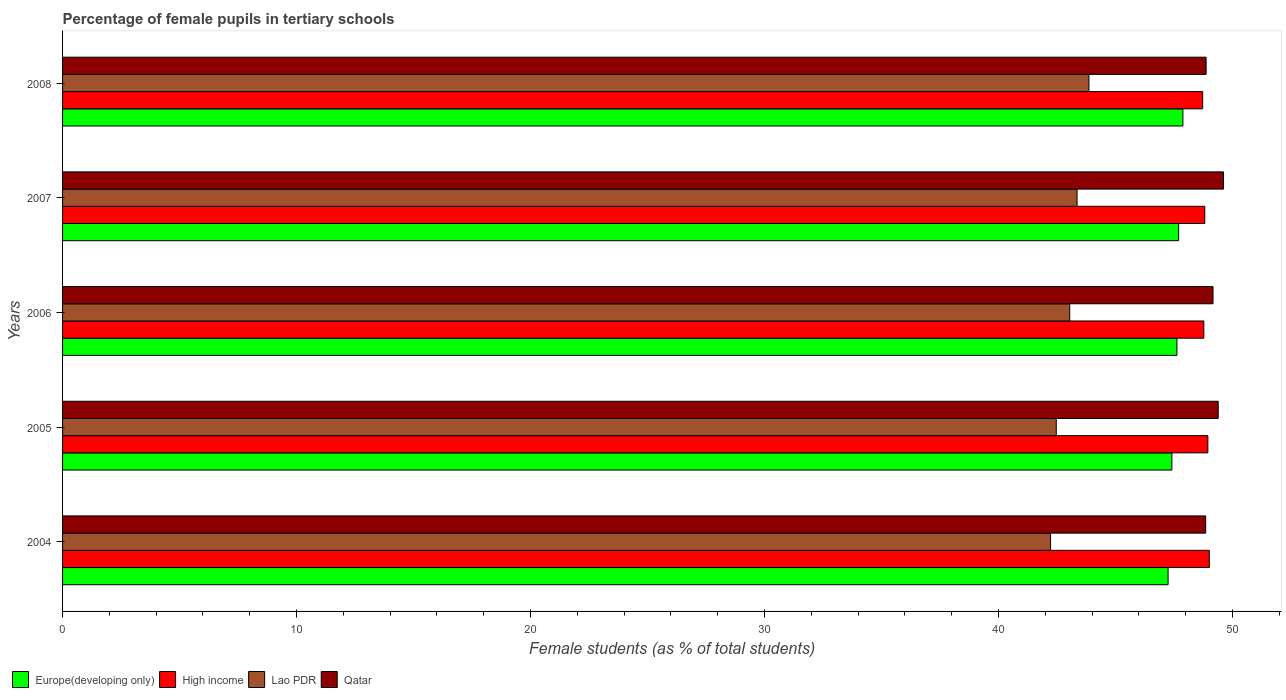How many different coloured bars are there?
Ensure brevity in your answer.  4. How many groups of bars are there?
Your answer should be compact. 5. Are the number of bars per tick equal to the number of legend labels?
Provide a short and direct response. Yes. How many bars are there on the 5th tick from the top?
Give a very brief answer. 4. What is the percentage of female pupils in tertiary schools in Lao PDR in 2006?
Your answer should be compact. 43.05. Across all years, what is the maximum percentage of female pupils in tertiary schools in Lao PDR?
Make the answer very short. 43.87. Across all years, what is the minimum percentage of female pupils in tertiary schools in Lao PDR?
Your answer should be compact. 42.23. In which year was the percentage of female pupils in tertiary schools in Qatar maximum?
Your answer should be very brief. 2007. What is the total percentage of female pupils in tertiary schools in Europe(developing only) in the graph?
Offer a very short reply. 237.87. What is the difference between the percentage of female pupils in tertiary schools in High income in 2004 and that in 2005?
Offer a very short reply. 0.06. What is the difference between the percentage of female pupils in tertiary schools in Europe(developing only) in 2004 and the percentage of female pupils in tertiary schools in Qatar in 2008?
Make the answer very short. -1.62. What is the average percentage of female pupils in tertiary schools in High income per year?
Provide a short and direct response. 48.85. In the year 2004, what is the difference between the percentage of female pupils in tertiary schools in High income and percentage of female pupils in tertiary schools in Europe(developing only)?
Your answer should be compact. 1.76. What is the ratio of the percentage of female pupils in tertiary schools in High income in 2005 to that in 2008?
Keep it short and to the point. 1. What is the difference between the highest and the second highest percentage of female pupils in tertiary schools in High income?
Provide a short and direct response. 0.06. What is the difference between the highest and the lowest percentage of female pupils in tertiary schools in Lao PDR?
Your answer should be very brief. 1.64. Is it the case that in every year, the sum of the percentage of female pupils in tertiary schools in Europe(developing only) and percentage of female pupils in tertiary schools in Qatar is greater than the sum of percentage of female pupils in tertiary schools in High income and percentage of female pupils in tertiary schools in Lao PDR?
Give a very brief answer. Yes. What does the 3rd bar from the top in 2004 represents?
Your answer should be compact. High income. What does the 4th bar from the bottom in 2007 represents?
Offer a terse response. Qatar. How many bars are there?
Your answer should be very brief. 20. Are the values on the major ticks of X-axis written in scientific E-notation?
Make the answer very short. No. How are the legend labels stacked?
Offer a very short reply. Horizontal. What is the title of the graph?
Offer a terse response. Percentage of female pupils in tertiary schools. Does "Suriname" appear as one of the legend labels in the graph?
Offer a terse response. No. What is the label or title of the X-axis?
Provide a succinct answer. Female students (as % of total students). What is the Female students (as % of total students) of Europe(developing only) in 2004?
Ensure brevity in your answer.  47.25. What is the Female students (as % of total students) in High income in 2004?
Your response must be concise. 49.01. What is the Female students (as % of total students) of Lao PDR in 2004?
Offer a very short reply. 42.23. What is the Female students (as % of total students) in Qatar in 2004?
Offer a terse response. 48.86. What is the Female students (as % of total students) of Europe(developing only) in 2005?
Offer a very short reply. 47.41. What is the Female students (as % of total students) in High income in 2005?
Offer a terse response. 48.95. What is the Female students (as % of total students) of Lao PDR in 2005?
Your answer should be very brief. 42.47. What is the Female students (as % of total students) in Qatar in 2005?
Keep it short and to the point. 49.39. What is the Female students (as % of total students) in Europe(developing only) in 2006?
Your answer should be compact. 47.63. What is the Female students (as % of total students) of High income in 2006?
Offer a very short reply. 48.78. What is the Female students (as % of total students) in Lao PDR in 2006?
Ensure brevity in your answer.  43.05. What is the Female students (as % of total students) in Qatar in 2006?
Provide a short and direct response. 49.17. What is the Female students (as % of total students) of Europe(developing only) in 2007?
Provide a short and direct response. 47.7. What is the Female students (as % of total students) of High income in 2007?
Make the answer very short. 48.82. What is the Female students (as % of total students) in Lao PDR in 2007?
Provide a succinct answer. 43.36. What is the Female students (as % of total students) in Qatar in 2007?
Ensure brevity in your answer.  49.61. What is the Female students (as % of total students) in Europe(developing only) in 2008?
Your response must be concise. 47.88. What is the Female students (as % of total students) in High income in 2008?
Keep it short and to the point. 48.72. What is the Female students (as % of total students) in Lao PDR in 2008?
Provide a succinct answer. 43.87. What is the Female students (as % of total students) of Qatar in 2008?
Provide a short and direct response. 48.87. Across all years, what is the maximum Female students (as % of total students) in Europe(developing only)?
Provide a succinct answer. 47.88. Across all years, what is the maximum Female students (as % of total students) in High income?
Offer a very short reply. 49.01. Across all years, what is the maximum Female students (as % of total students) in Lao PDR?
Your answer should be very brief. 43.87. Across all years, what is the maximum Female students (as % of total students) in Qatar?
Provide a succinct answer. 49.61. Across all years, what is the minimum Female students (as % of total students) in Europe(developing only)?
Offer a terse response. 47.25. Across all years, what is the minimum Female students (as % of total students) in High income?
Provide a short and direct response. 48.72. Across all years, what is the minimum Female students (as % of total students) in Lao PDR?
Your response must be concise. 42.23. Across all years, what is the minimum Female students (as % of total students) of Qatar?
Your answer should be very brief. 48.86. What is the total Female students (as % of total students) in Europe(developing only) in the graph?
Provide a succinct answer. 237.87. What is the total Female students (as % of total students) in High income in the graph?
Your response must be concise. 244.27. What is the total Female students (as % of total students) of Lao PDR in the graph?
Ensure brevity in your answer.  214.96. What is the total Female students (as % of total students) of Qatar in the graph?
Offer a very short reply. 245.9. What is the difference between the Female students (as % of total students) in Europe(developing only) in 2004 and that in 2005?
Make the answer very short. -0.16. What is the difference between the Female students (as % of total students) in High income in 2004 and that in 2005?
Offer a terse response. 0.06. What is the difference between the Female students (as % of total students) of Lao PDR in 2004 and that in 2005?
Offer a terse response. -0.24. What is the difference between the Female students (as % of total students) of Qatar in 2004 and that in 2005?
Provide a succinct answer. -0.54. What is the difference between the Female students (as % of total students) in Europe(developing only) in 2004 and that in 2006?
Your answer should be compact. -0.38. What is the difference between the Female students (as % of total students) of High income in 2004 and that in 2006?
Provide a short and direct response. 0.23. What is the difference between the Female students (as % of total students) of Lao PDR in 2004 and that in 2006?
Provide a succinct answer. -0.82. What is the difference between the Female students (as % of total students) of Qatar in 2004 and that in 2006?
Your answer should be compact. -0.31. What is the difference between the Female students (as % of total students) in Europe(developing only) in 2004 and that in 2007?
Give a very brief answer. -0.45. What is the difference between the Female students (as % of total students) of High income in 2004 and that in 2007?
Provide a short and direct response. 0.19. What is the difference between the Female students (as % of total students) of Lao PDR in 2004 and that in 2007?
Give a very brief answer. -1.13. What is the difference between the Female students (as % of total students) in Qatar in 2004 and that in 2007?
Make the answer very short. -0.76. What is the difference between the Female students (as % of total students) in Europe(developing only) in 2004 and that in 2008?
Your answer should be compact. -0.63. What is the difference between the Female students (as % of total students) of High income in 2004 and that in 2008?
Your response must be concise. 0.28. What is the difference between the Female students (as % of total students) in Lao PDR in 2004 and that in 2008?
Ensure brevity in your answer.  -1.64. What is the difference between the Female students (as % of total students) of Qatar in 2004 and that in 2008?
Offer a very short reply. -0.02. What is the difference between the Female students (as % of total students) of Europe(developing only) in 2005 and that in 2006?
Offer a terse response. -0.22. What is the difference between the Female students (as % of total students) in High income in 2005 and that in 2006?
Offer a terse response. 0.17. What is the difference between the Female students (as % of total students) in Lao PDR in 2005 and that in 2006?
Offer a terse response. -0.58. What is the difference between the Female students (as % of total students) in Qatar in 2005 and that in 2006?
Offer a very short reply. 0.22. What is the difference between the Female students (as % of total students) of Europe(developing only) in 2005 and that in 2007?
Offer a very short reply. -0.29. What is the difference between the Female students (as % of total students) of High income in 2005 and that in 2007?
Provide a short and direct response. 0.13. What is the difference between the Female students (as % of total students) in Lao PDR in 2005 and that in 2007?
Your answer should be very brief. -0.89. What is the difference between the Female students (as % of total students) of Qatar in 2005 and that in 2007?
Make the answer very short. -0.22. What is the difference between the Female students (as % of total students) in Europe(developing only) in 2005 and that in 2008?
Make the answer very short. -0.47. What is the difference between the Female students (as % of total students) in High income in 2005 and that in 2008?
Provide a short and direct response. 0.22. What is the difference between the Female students (as % of total students) in Lao PDR in 2005 and that in 2008?
Your response must be concise. -1.4. What is the difference between the Female students (as % of total students) in Qatar in 2005 and that in 2008?
Offer a very short reply. 0.52. What is the difference between the Female students (as % of total students) of Europe(developing only) in 2006 and that in 2007?
Make the answer very short. -0.07. What is the difference between the Female students (as % of total students) in High income in 2006 and that in 2007?
Provide a short and direct response. -0.04. What is the difference between the Female students (as % of total students) of Lao PDR in 2006 and that in 2007?
Make the answer very short. -0.31. What is the difference between the Female students (as % of total students) in Qatar in 2006 and that in 2007?
Your answer should be compact. -0.45. What is the difference between the Female students (as % of total students) of Europe(developing only) in 2006 and that in 2008?
Your response must be concise. -0.25. What is the difference between the Female students (as % of total students) in High income in 2006 and that in 2008?
Provide a short and direct response. 0.05. What is the difference between the Female students (as % of total students) in Lao PDR in 2006 and that in 2008?
Your answer should be compact. -0.82. What is the difference between the Female students (as % of total students) in Qatar in 2006 and that in 2008?
Your response must be concise. 0.29. What is the difference between the Female students (as % of total students) in Europe(developing only) in 2007 and that in 2008?
Your response must be concise. -0.18. What is the difference between the Female students (as % of total students) of High income in 2007 and that in 2008?
Provide a short and direct response. 0.09. What is the difference between the Female students (as % of total students) of Lao PDR in 2007 and that in 2008?
Offer a terse response. -0.51. What is the difference between the Female students (as % of total students) of Qatar in 2007 and that in 2008?
Your answer should be very brief. 0.74. What is the difference between the Female students (as % of total students) in Europe(developing only) in 2004 and the Female students (as % of total students) in High income in 2005?
Your answer should be compact. -1.7. What is the difference between the Female students (as % of total students) in Europe(developing only) in 2004 and the Female students (as % of total students) in Lao PDR in 2005?
Provide a succinct answer. 4.78. What is the difference between the Female students (as % of total students) of Europe(developing only) in 2004 and the Female students (as % of total students) of Qatar in 2005?
Offer a terse response. -2.14. What is the difference between the Female students (as % of total students) in High income in 2004 and the Female students (as % of total students) in Lao PDR in 2005?
Your response must be concise. 6.54. What is the difference between the Female students (as % of total students) in High income in 2004 and the Female students (as % of total students) in Qatar in 2005?
Keep it short and to the point. -0.38. What is the difference between the Female students (as % of total students) in Lao PDR in 2004 and the Female students (as % of total students) in Qatar in 2005?
Your answer should be very brief. -7.17. What is the difference between the Female students (as % of total students) in Europe(developing only) in 2004 and the Female students (as % of total students) in High income in 2006?
Keep it short and to the point. -1.53. What is the difference between the Female students (as % of total students) in Europe(developing only) in 2004 and the Female students (as % of total students) in Lao PDR in 2006?
Your response must be concise. 4.2. What is the difference between the Female students (as % of total students) in Europe(developing only) in 2004 and the Female students (as % of total students) in Qatar in 2006?
Your answer should be compact. -1.92. What is the difference between the Female students (as % of total students) of High income in 2004 and the Female students (as % of total students) of Lao PDR in 2006?
Your answer should be very brief. 5.96. What is the difference between the Female students (as % of total students) in High income in 2004 and the Female students (as % of total students) in Qatar in 2006?
Give a very brief answer. -0.16. What is the difference between the Female students (as % of total students) in Lao PDR in 2004 and the Female students (as % of total students) in Qatar in 2006?
Your answer should be compact. -6.94. What is the difference between the Female students (as % of total students) in Europe(developing only) in 2004 and the Female students (as % of total students) in High income in 2007?
Give a very brief answer. -1.57. What is the difference between the Female students (as % of total students) in Europe(developing only) in 2004 and the Female students (as % of total students) in Lao PDR in 2007?
Make the answer very short. 3.89. What is the difference between the Female students (as % of total students) of Europe(developing only) in 2004 and the Female students (as % of total students) of Qatar in 2007?
Make the answer very short. -2.37. What is the difference between the Female students (as % of total students) in High income in 2004 and the Female students (as % of total students) in Lao PDR in 2007?
Keep it short and to the point. 5.65. What is the difference between the Female students (as % of total students) in High income in 2004 and the Female students (as % of total students) in Qatar in 2007?
Make the answer very short. -0.6. What is the difference between the Female students (as % of total students) of Lao PDR in 2004 and the Female students (as % of total students) of Qatar in 2007?
Provide a succinct answer. -7.39. What is the difference between the Female students (as % of total students) in Europe(developing only) in 2004 and the Female students (as % of total students) in High income in 2008?
Offer a very short reply. -1.48. What is the difference between the Female students (as % of total students) in Europe(developing only) in 2004 and the Female students (as % of total students) in Lao PDR in 2008?
Provide a short and direct response. 3.38. What is the difference between the Female students (as % of total students) in Europe(developing only) in 2004 and the Female students (as % of total students) in Qatar in 2008?
Your answer should be compact. -1.62. What is the difference between the Female students (as % of total students) in High income in 2004 and the Female students (as % of total students) in Lao PDR in 2008?
Give a very brief answer. 5.14. What is the difference between the Female students (as % of total students) of High income in 2004 and the Female students (as % of total students) of Qatar in 2008?
Your answer should be compact. 0.14. What is the difference between the Female students (as % of total students) in Lao PDR in 2004 and the Female students (as % of total students) in Qatar in 2008?
Ensure brevity in your answer.  -6.65. What is the difference between the Female students (as % of total students) in Europe(developing only) in 2005 and the Female students (as % of total students) in High income in 2006?
Your response must be concise. -1.36. What is the difference between the Female students (as % of total students) in Europe(developing only) in 2005 and the Female students (as % of total students) in Lao PDR in 2006?
Make the answer very short. 4.37. What is the difference between the Female students (as % of total students) of Europe(developing only) in 2005 and the Female students (as % of total students) of Qatar in 2006?
Provide a succinct answer. -1.76. What is the difference between the Female students (as % of total students) in High income in 2005 and the Female students (as % of total students) in Lao PDR in 2006?
Make the answer very short. 5.9. What is the difference between the Female students (as % of total students) in High income in 2005 and the Female students (as % of total students) in Qatar in 2006?
Provide a succinct answer. -0.22. What is the difference between the Female students (as % of total students) in Lao PDR in 2005 and the Female students (as % of total students) in Qatar in 2006?
Your response must be concise. -6.7. What is the difference between the Female students (as % of total students) of Europe(developing only) in 2005 and the Female students (as % of total students) of High income in 2007?
Give a very brief answer. -1.41. What is the difference between the Female students (as % of total students) of Europe(developing only) in 2005 and the Female students (as % of total students) of Lao PDR in 2007?
Provide a short and direct response. 4.05. What is the difference between the Female students (as % of total students) in Europe(developing only) in 2005 and the Female students (as % of total students) in Qatar in 2007?
Ensure brevity in your answer.  -2.2. What is the difference between the Female students (as % of total students) in High income in 2005 and the Female students (as % of total students) in Lao PDR in 2007?
Your answer should be very brief. 5.59. What is the difference between the Female students (as % of total students) of High income in 2005 and the Female students (as % of total students) of Qatar in 2007?
Your response must be concise. -0.67. What is the difference between the Female students (as % of total students) in Lao PDR in 2005 and the Female students (as % of total students) in Qatar in 2007?
Offer a terse response. -7.14. What is the difference between the Female students (as % of total students) in Europe(developing only) in 2005 and the Female students (as % of total students) in High income in 2008?
Offer a terse response. -1.31. What is the difference between the Female students (as % of total students) in Europe(developing only) in 2005 and the Female students (as % of total students) in Lao PDR in 2008?
Give a very brief answer. 3.54. What is the difference between the Female students (as % of total students) of Europe(developing only) in 2005 and the Female students (as % of total students) of Qatar in 2008?
Provide a short and direct response. -1.46. What is the difference between the Female students (as % of total students) of High income in 2005 and the Female students (as % of total students) of Lao PDR in 2008?
Your answer should be compact. 5.08. What is the difference between the Female students (as % of total students) in High income in 2005 and the Female students (as % of total students) in Qatar in 2008?
Provide a short and direct response. 0.07. What is the difference between the Female students (as % of total students) in Lao PDR in 2005 and the Female students (as % of total students) in Qatar in 2008?
Provide a succinct answer. -6.4. What is the difference between the Female students (as % of total students) of Europe(developing only) in 2006 and the Female students (as % of total students) of High income in 2007?
Give a very brief answer. -1.19. What is the difference between the Female students (as % of total students) of Europe(developing only) in 2006 and the Female students (as % of total students) of Lao PDR in 2007?
Your response must be concise. 4.27. What is the difference between the Female students (as % of total students) of Europe(developing only) in 2006 and the Female students (as % of total students) of Qatar in 2007?
Offer a terse response. -1.99. What is the difference between the Female students (as % of total students) of High income in 2006 and the Female students (as % of total students) of Lao PDR in 2007?
Offer a terse response. 5.42. What is the difference between the Female students (as % of total students) in High income in 2006 and the Female students (as % of total students) in Qatar in 2007?
Provide a short and direct response. -0.84. What is the difference between the Female students (as % of total students) in Lao PDR in 2006 and the Female students (as % of total students) in Qatar in 2007?
Make the answer very short. -6.57. What is the difference between the Female students (as % of total students) of Europe(developing only) in 2006 and the Female students (as % of total students) of High income in 2008?
Provide a succinct answer. -1.1. What is the difference between the Female students (as % of total students) in Europe(developing only) in 2006 and the Female students (as % of total students) in Lao PDR in 2008?
Make the answer very short. 3.76. What is the difference between the Female students (as % of total students) of Europe(developing only) in 2006 and the Female students (as % of total students) of Qatar in 2008?
Your answer should be very brief. -1.25. What is the difference between the Female students (as % of total students) in High income in 2006 and the Female students (as % of total students) in Lao PDR in 2008?
Your response must be concise. 4.91. What is the difference between the Female students (as % of total students) in High income in 2006 and the Female students (as % of total students) in Qatar in 2008?
Provide a succinct answer. -0.1. What is the difference between the Female students (as % of total students) in Lao PDR in 2006 and the Female students (as % of total students) in Qatar in 2008?
Offer a very short reply. -5.83. What is the difference between the Female students (as % of total students) in Europe(developing only) in 2007 and the Female students (as % of total students) in High income in 2008?
Your answer should be very brief. -1.02. What is the difference between the Female students (as % of total students) in Europe(developing only) in 2007 and the Female students (as % of total students) in Lao PDR in 2008?
Make the answer very short. 3.83. What is the difference between the Female students (as % of total students) of Europe(developing only) in 2007 and the Female students (as % of total students) of Qatar in 2008?
Your answer should be very brief. -1.17. What is the difference between the Female students (as % of total students) in High income in 2007 and the Female students (as % of total students) in Lao PDR in 2008?
Ensure brevity in your answer.  4.95. What is the difference between the Female students (as % of total students) in High income in 2007 and the Female students (as % of total students) in Qatar in 2008?
Give a very brief answer. -0.06. What is the difference between the Female students (as % of total students) in Lao PDR in 2007 and the Female students (as % of total students) in Qatar in 2008?
Offer a terse response. -5.52. What is the average Female students (as % of total students) of Europe(developing only) per year?
Provide a succinct answer. 47.57. What is the average Female students (as % of total students) in High income per year?
Your answer should be compact. 48.85. What is the average Female students (as % of total students) of Lao PDR per year?
Keep it short and to the point. 42.99. What is the average Female students (as % of total students) in Qatar per year?
Provide a succinct answer. 49.18. In the year 2004, what is the difference between the Female students (as % of total students) of Europe(developing only) and Female students (as % of total students) of High income?
Provide a short and direct response. -1.76. In the year 2004, what is the difference between the Female students (as % of total students) in Europe(developing only) and Female students (as % of total students) in Lao PDR?
Provide a succinct answer. 5.02. In the year 2004, what is the difference between the Female students (as % of total students) in Europe(developing only) and Female students (as % of total students) in Qatar?
Your response must be concise. -1.61. In the year 2004, what is the difference between the Female students (as % of total students) in High income and Female students (as % of total students) in Lao PDR?
Provide a succinct answer. 6.78. In the year 2004, what is the difference between the Female students (as % of total students) in High income and Female students (as % of total students) in Qatar?
Your answer should be very brief. 0.15. In the year 2004, what is the difference between the Female students (as % of total students) of Lao PDR and Female students (as % of total students) of Qatar?
Offer a very short reply. -6.63. In the year 2005, what is the difference between the Female students (as % of total students) of Europe(developing only) and Female students (as % of total students) of High income?
Offer a very short reply. -1.54. In the year 2005, what is the difference between the Female students (as % of total students) of Europe(developing only) and Female students (as % of total students) of Lao PDR?
Offer a very short reply. 4.94. In the year 2005, what is the difference between the Female students (as % of total students) in Europe(developing only) and Female students (as % of total students) in Qatar?
Keep it short and to the point. -1.98. In the year 2005, what is the difference between the Female students (as % of total students) in High income and Female students (as % of total students) in Lao PDR?
Offer a terse response. 6.48. In the year 2005, what is the difference between the Female students (as % of total students) of High income and Female students (as % of total students) of Qatar?
Provide a short and direct response. -0.44. In the year 2005, what is the difference between the Female students (as % of total students) in Lao PDR and Female students (as % of total students) in Qatar?
Provide a short and direct response. -6.92. In the year 2006, what is the difference between the Female students (as % of total students) in Europe(developing only) and Female students (as % of total students) in High income?
Make the answer very short. -1.15. In the year 2006, what is the difference between the Female students (as % of total students) in Europe(developing only) and Female students (as % of total students) in Lao PDR?
Ensure brevity in your answer.  4.58. In the year 2006, what is the difference between the Female students (as % of total students) of Europe(developing only) and Female students (as % of total students) of Qatar?
Ensure brevity in your answer.  -1.54. In the year 2006, what is the difference between the Female students (as % of total students) of High income and Female students (as % of total students) of Lao PDR?
Ensure brevity in your answer.  5.73. In the year 2006, what is the difference between the Female students (as % of total students) of High income and Female students (as % of total students) of Qatar?
Make the answer very short. -0.39. In the year 2006, what is the difference between the Female students (as % of total students) of Lao PDR and Female students (as % of total students) of Qatar?
Provide a short and direct response. -6.12. In the year 2007, what is the difference between the Female students (as % of total students) in Europe(developing only) and Female students (as % of total students) in High income?
Give a very brief answer. -1.12. In the year 2007, what is the difference between the Female students (as % of total students) in Europe(developing only) and Female students (as % of total students) in Lao PDR?
Your response must be concise. 4.34. In the year 2007, what is the difference between the Female students (as % of total students) of Europe(developing only) and Female students (as % of total students) of Qatar?
Provide a succinct answer. -1.91. In the year 2007, what is the difference between the Female students (as % of total students) of High income and Female students (as % of total students) of Lao PDR?
Your answer should be very brief. 5.46. In the year 2007, what is the difference between the Female students (as % of total students) of High income and Female students (as % of total students) of Qatar?
Your answer should be very brief. -0.8. In the year 2007, what is the difference between the Female students (as % of total students) in Lao PDR and Female students (as % of total students) in Qatar?
Your answer should be very brief. -6.26. In the year 2008, what is the difference between the Female students (as % of total students) in Europe(developing only) and Female students (as % of total students) in High income?
Ensure brevity in your answer.  -0.84. In the year 2008, what is the difference between the Female students (as % of total students) of Europe(developing only) and Female students (as % of total students) of Lao PDR?
Provide a succinct answer. 4.02. In the year 2008, what is the difference between the Female students (as % of total students) in Europe(developing only) and Female students (as % of total students) in Qatar?
Provide a succinct answer. -0.99. In the year 2008, what is the difference between the Female students (as % of total students) of High income and Female students (as % of total students) of Lao PDR?
Make the answer very short. 4.86. In the year 2008, what is the difference between the Female students (as % of total students) of High income and Female students (as % of total students) of Qatar?
Ensure brevity in your answer.  -0.15. In the year 2008, what is the difference between the Female students (as % of total students) of Lao PDR and Female students (as % of total students) of Qatar?
Keep it short and to the point. -5.01. What is the ratio of the Female students (as % of total students) in Europe(developing only) in 2004 to that in 2005?
Keep it short and to the point. 1. What is the ratio of the Female students (as % of total students) of Qatar in 2004 to that in 2005?
Your answer should be compact. 0.99. What is the ratio of the Female students (as % of total students) of Europe(developing only) in 2004 to that in 2006?
Your answer should be compact. 0.99. What is the ratio of the Female students (as % of total students) of High income in 2004 to that in 2006?
Offer a terse response. 1. What is the ratio of the Female students (as % of total students) of Lao PDR in 2004 to that in 2006?
Your response must be concise. 0.98. What is the ratio of the Female students (as % of total students) of Qatar in 2004 to that in 2006?
Offer a very short reply. 0.99. What is the ratio of the Female students (as % of total students) of Lao PDR in 2004 to that in 2007?
Offer a terse response. 0.97. What is the ratio of the Female students (as % of total students) of Qatar in 2004 to that in 2007?
Keep it short and to the point. 0.98. What is the ratio of the Female students (as % of total students) in Europe(developing only) in 2004 to that in 2008?
Offer a very short reply. 0.99. What is the ratio of the Female students (as % of total students) of High income in 2004 to that in 2008?
Keep it short and to the point. 1.01. What is the ratio of the Female students (as % of total students) in Lao PDR in 2004 to that in 2008?
Keep it short and to the point. 0.96. What is the ratio of the Female students (as % of total students) of Qatar in 2004 to that in 2008?
Provide a short and direct response. 1. What is the ratio of the Female students (as % of total students) of Europe(developing only) in 2005 to that in 2006?
Your answer should be compact. 1. What is the ratio of the Female students (as % of total students) in Lao PDR in 2005 to that in 2006?
Your response must be concise. 0.99. What is the ratio of the Female students (as % of total students) in Qatar in 2005 to that in 2006?
Your answer should be very brief. 1. What is the ratio of the Female students (as % of total students) in Europe(developing only) in 2005 to that in 2007?
Your answer should be compact. 0.99. What is the ratio of the Female students (as % of total students) in Lao PDR in 2005 to that in 2007?
Keep it short and to the point. 0.98. What is the ratio of the Female students (as % of total students) in Qatar in 2005 to that in 2007?
Your answer should be very brief. 1. What is the ratio of the Female students (as % of total students) of Europe(developing only) in 2005 to that in 2008?
Provide a succinct answer. 0.99. What is the ratio of the Female students (as % of total students) in Lao PDR in 2005 to that in 2008?
Offer a terse response. 0.97. What is the ratio of the Female students (as % of total students) of Qatar in 2005 to that in 2008?
Your answer should be very brief. 1.01. What is the ratio of the Female students (as % of total students) of Europe(developing only) in 2006 to that in 2007?
Ensure brevity in your answer.  1. What is the ratio of the Female students (as % of total students) of Qatar in 2006 to that in 2007?
Provide a short and direct response. 0.99. What is the ratio of the Female students (as % of total students) in Europe(developing only) in 2006 to that in 2008?
Ensure brevity in your answer.  0.99. What is the ratio of the Female students (as % of total students) of High income in 2006 to that in 2008?
Make the answer very short. 1. What is the ratio of the Female students (as % of total students) in Lao PDR in 2006 to that in 2008?
Ensure brevity in your answer.  0.98. What is the ratio of the Female students (as % of total students) of Qatar in 2006 to that in 2008?
Your answer should be very brief. 1.01. What is the ratio of the Female students (as % of total students) in High income in 2007 to that in 2008?
Offer a terse response. 1. What is the ratio of the Female students (as % of total students) of Lao PDR in 2007 to that in 2008?
Offer a very short reply. 0.99. What is the ratio of the Female students (as % of total students) in Qatar in 2007 to that in 2008?
Your answer should be very brief. 1.02. What is the difference between the highest and the second highest Female students (as % of total students) of Europe(developing only)?
Provide a short and direct response. 0.18. What is the difference between the highest and the second highest Female students (as % of total students) in High income?
Provide a short and direct response. 0.06. What is the difference between the highest and the second highest Female students (as % of total students) in Lao PDR?
Your answer should be very brief. 0.51. What is the difference between the highest and the second highest Female students (as % of total students) of Qatar?
Your answer should be compact. 0.22. What is the difference between the highest and the lowest Female students (as % of total students) in Europe(developing only)?
Your response must be concise. 0.63. What is the difference between the highest and the lowest Female students (as % of total students) of High income?
Keep it short and to the point. 0.28. What is the difference between the highest and the lowest Female students (as % of total students) in Lao PDR?
Give a very brief answer. 1.64. What is the difference between the highest and the lowest Female students (as % of total students) of Qatar?
Offer a terse response. 0.76. 